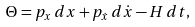Convert formula to latex. <formula><loc_0><loc_0><loc_500><loc_500>\Theta = p _ { x } \, d x + p _ { \dot { x } } \, d \dot { x } - H \, d t ,</formula> 